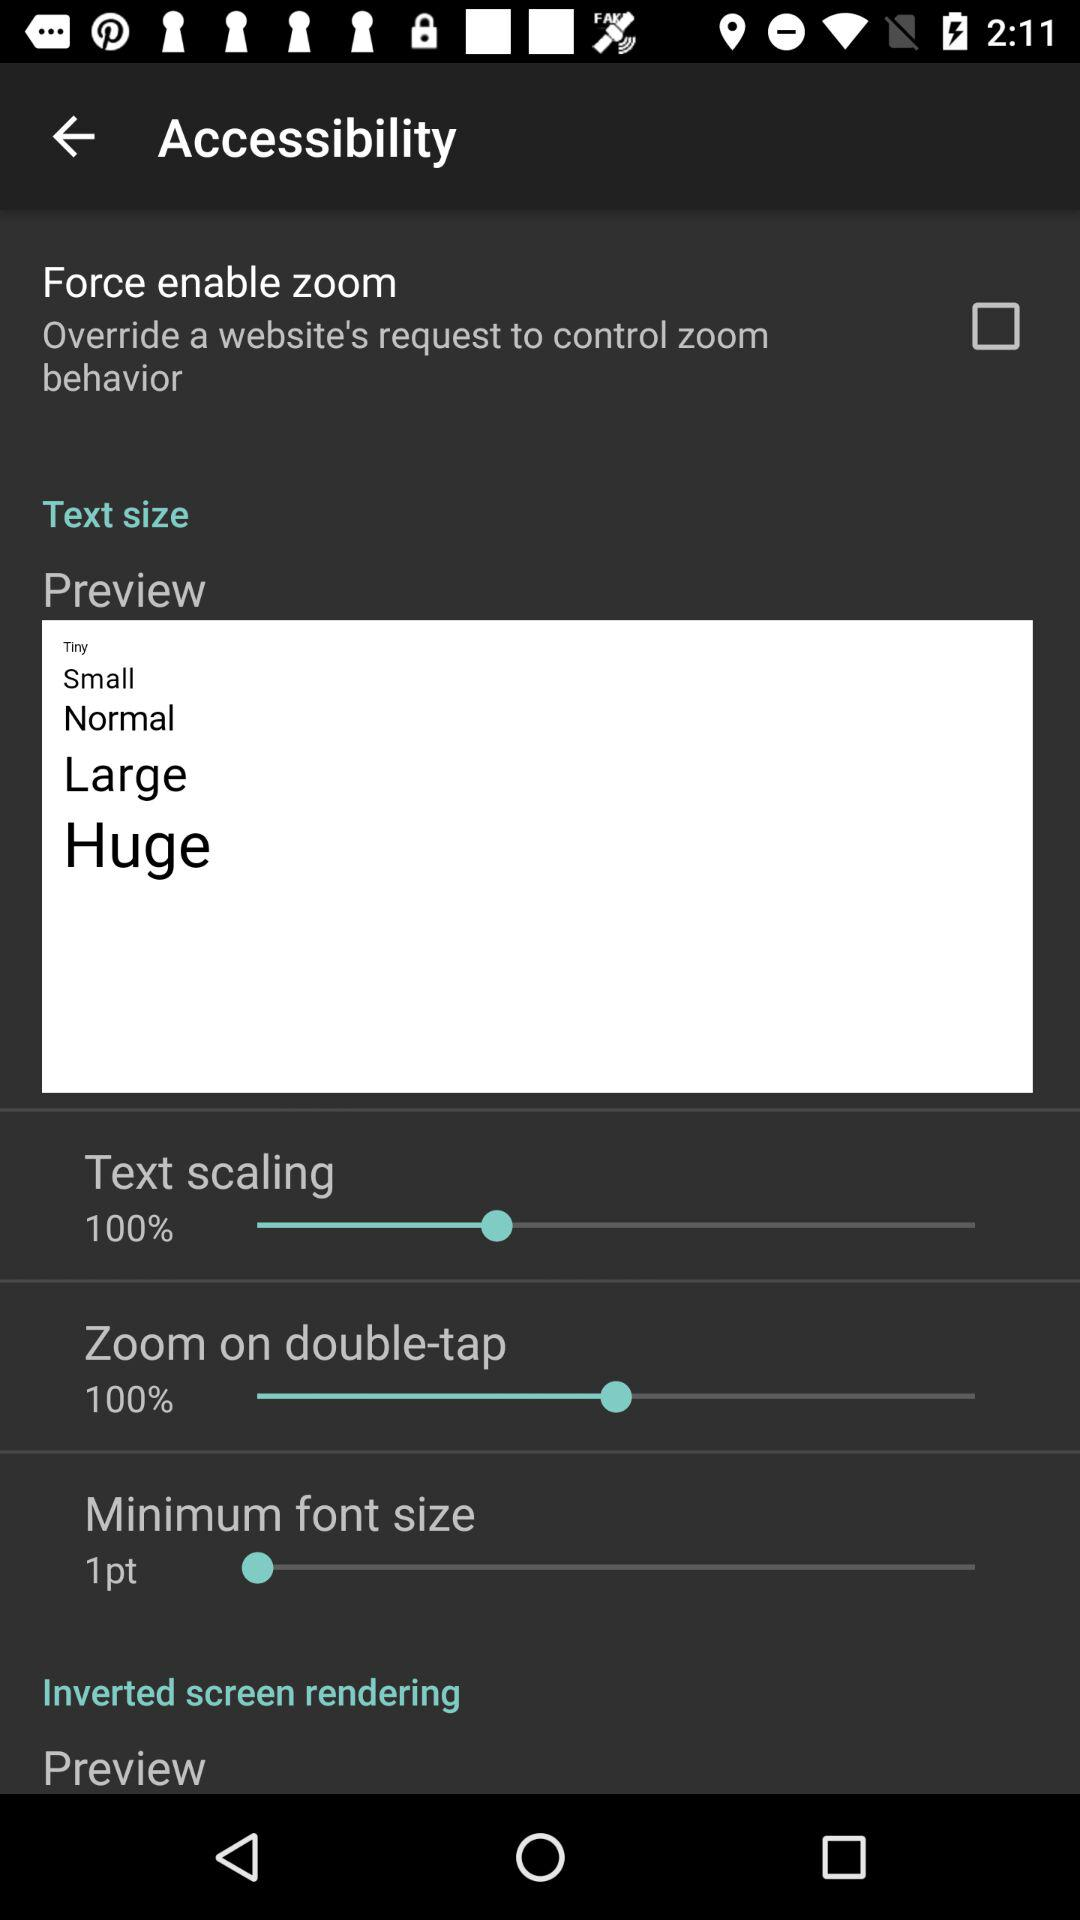What is the status of "Force enable zoom"? The status of "Force enable zoom" is "off". 